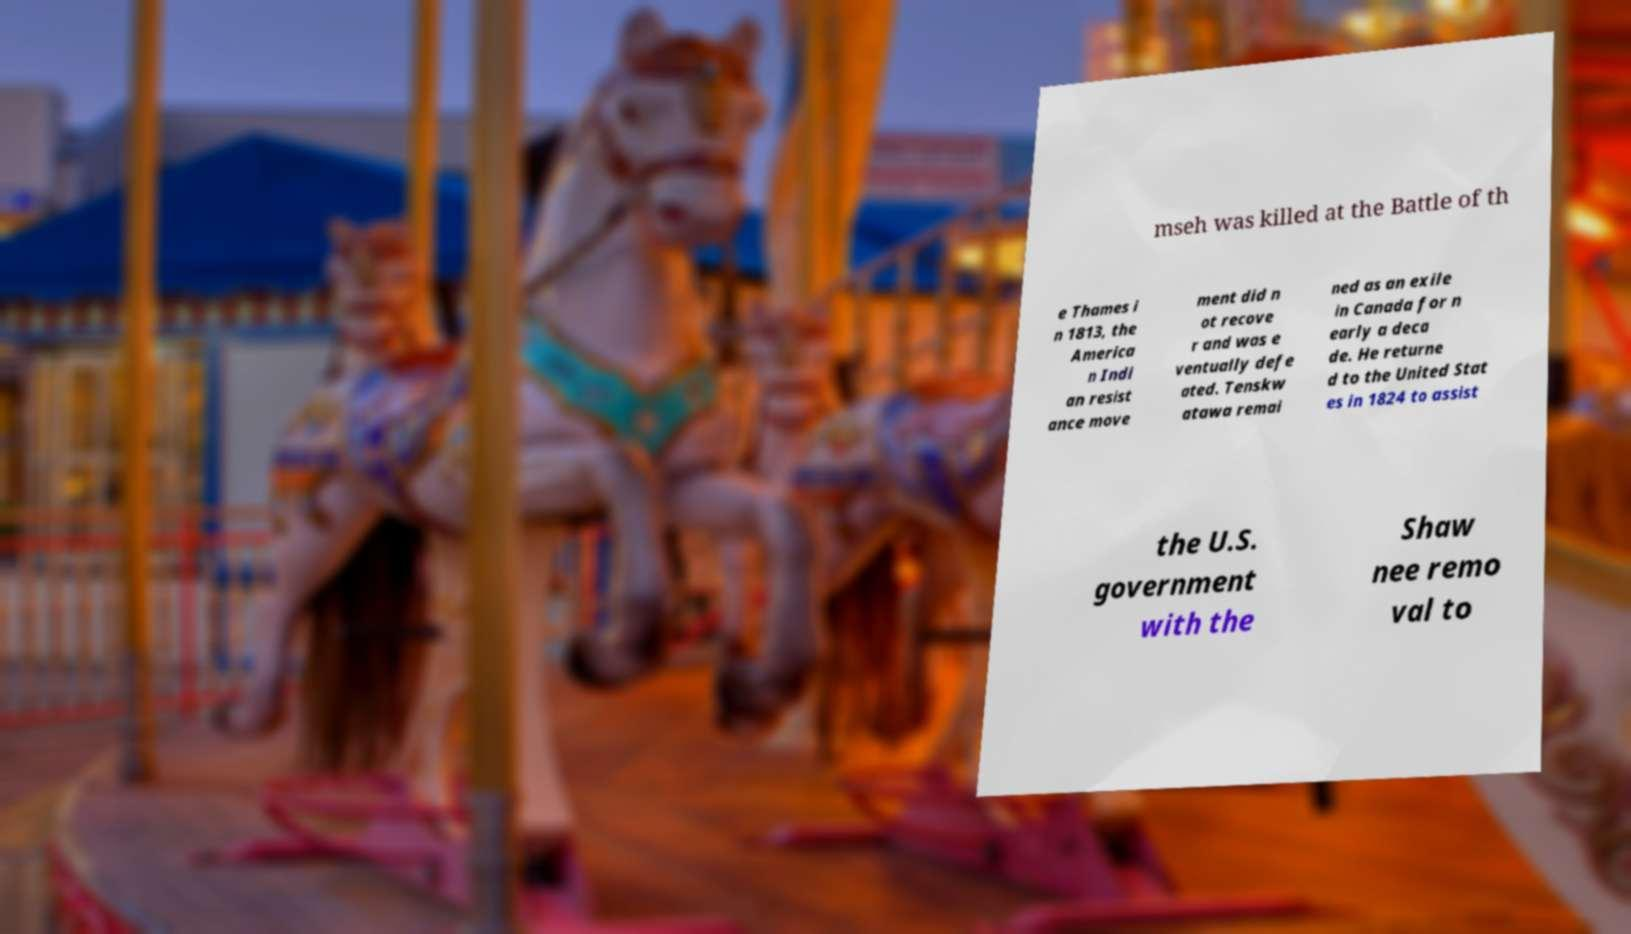I need the written content from this picture converted into text. Can you do that? mseh was killed at the Battle of th e Thames i n 1813, the America n Indi an resist ance move ment did n ot recove r and was e ventually defe ated. Tenskw atawa remai ned as an exile in Canada for n early a deca de. He returne d to the United Stat es in 1824 to assist the U.S. government with the Shaw nee remo val to 